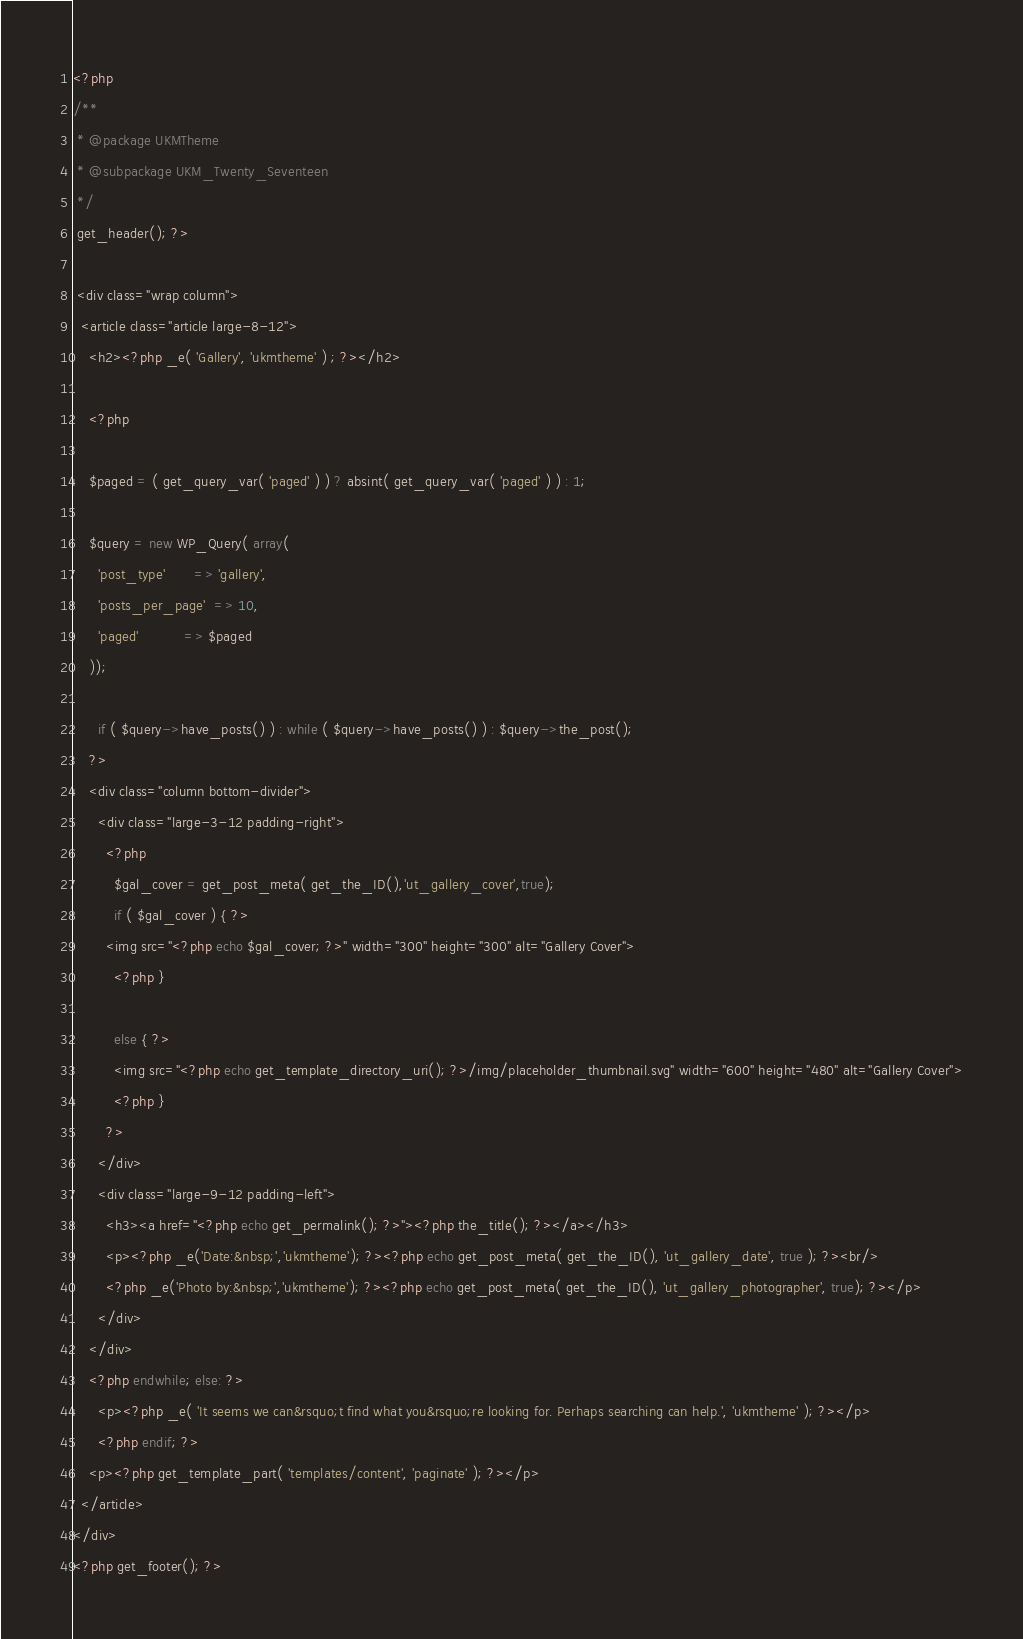Convert code to text. <code><loc_0><loc_0><loc_500><loc_500><_PHP_><?php
/**
 * @package UKMTheme
 * @subpackage UKM_Twenty_Seventeen
 */
 get_header(); ?>

 <div class="wrap column">
  <article class="article large-8-12">
    <h2><?php _e( 'Gallery', 'ukmtheme' ) ; ?></h2>

    <?php
    
    $paged = ( get_query_var( 'paged' ) ) ? absint( get_query_var( 'paged' ) ) : 1;

    $query = new WP_Query( array( 
      'post_type'       => 'gallery',
      'posts_per_page'  => 10,
      'paged'           => $paged
    ));
    
      if ( $query->have_posts() ) : while ( $query->have_posts() ) : $query->the_post();
    ?>
    <div class="column bottom-divider">
      <div class="large-3-12 padding-right">
        <?php
          $gal_cover = get_post_meta( get_the_ID(),'ut_gallery_cover',true);
          if ( $gal_cover ) { ?>
        <img src="<?php echo $gal_cover; ?>" width="300" height="300" alt="Gallery Cover">
          <?php }

          else { ?>
          <img src="<?php echo get_template_directory_uri(); ?>/img/placeholder_thumbnail.svg" width="600" height="480" alt="Gallery Cover">
          <?php }
        ?>
      </div>
      <div class="large-9-12 padding-left">
        <h3><a href="<?php echo get_permalink(); ?>"><?php the_title(); ?></a></h3>
        <p><?php _e('Date:&nbsp;','ukmtheme'); ?><?php echo get_post_meta( get_the_ID(), 'ut_gallery_date', true ); ?><br/>
        <?php _e('Photo by:&nbsp;','ukmtheme'); ?><?php echo get_post_meta( get_the_ID(), 'ut_gallery_photographer', true); ?></p>
      </div>
    </div>
    <?php endwhile; else: ?>
      <p><?php _e( 'It seems we can&rsquo;t find what you&rsquo;re looking for. Perhaps searching can help.', 'ukmtheme' ); ?></p>
      <?php endif; ?>
    <p><?php get_template_part( 'templates/content', 'paginate' ); ?></p>
  </article>
</div>
<?php get_footer(); ?></code> 